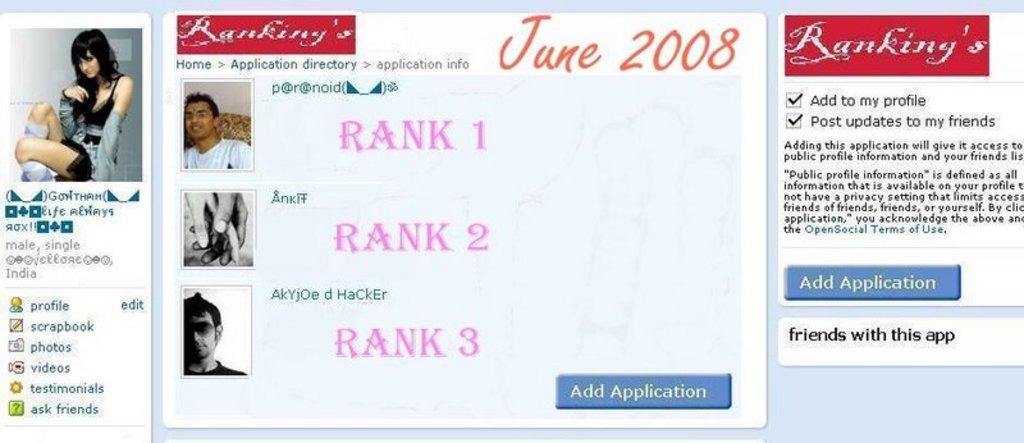What is the main subject of the image? The main subject of the image is a screenshot. What can be seen within the screenshot? The screenshot contains three profiles and text. What type of disease is mentioned in the text within the screenshot? There is no mention of a disease in the text within the screenshot. What color is the dress worn by the person in the screenshot? There is no person or dress visible in the screenshot; it only contains profiles and text. 